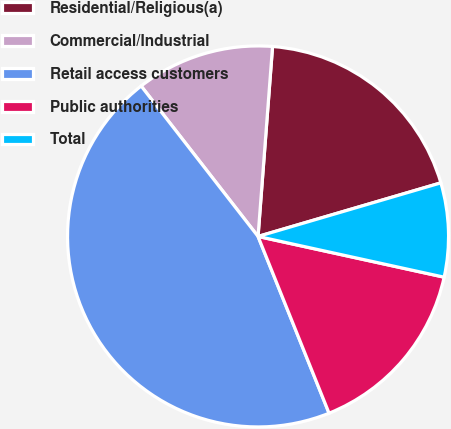Convert chart. <chart><loc_0><loc_0><loc_500><loc_500><pie_chart><fcel>Residential/Religious(a)<fcel>Commercial/Industrial<fcel>Retail access customers<fcel>Public authorities<fcel>Total<nl><fcel>19.25%<fcel>11.73%<fcel>45.57%<fcel>15.49%<fcel>7.97%<nl></chart> 